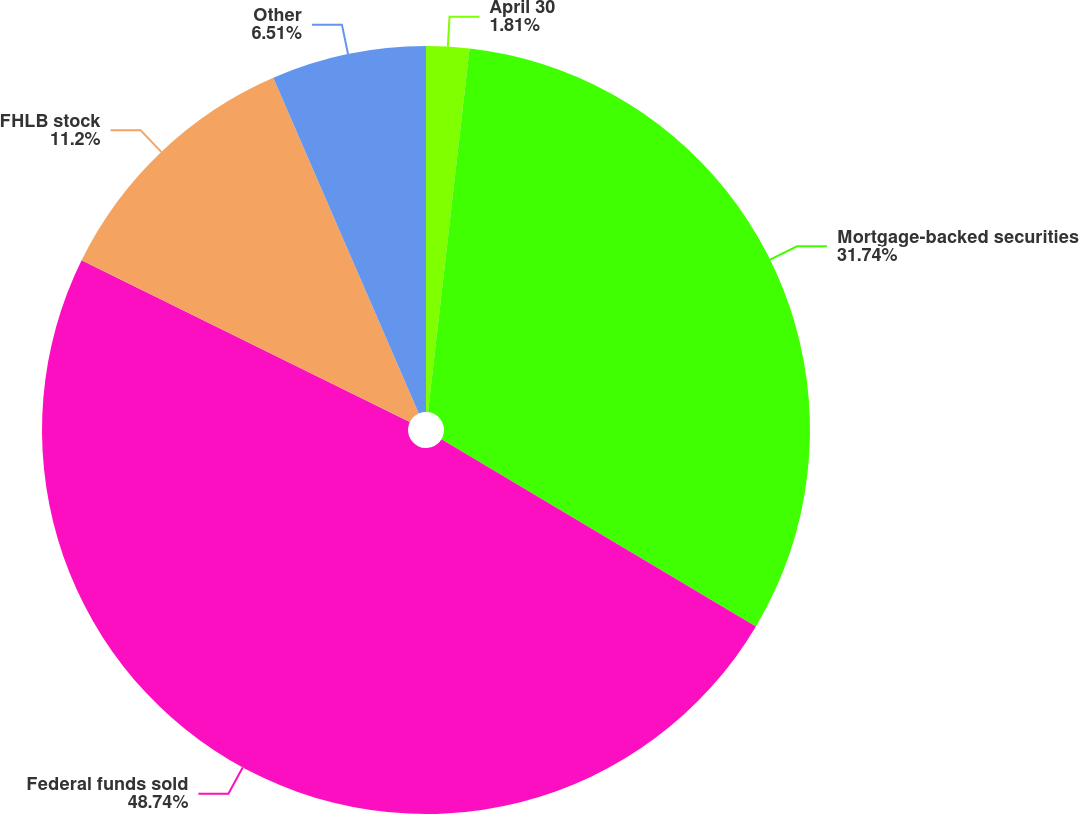<chart> <loc_0><loc_0><loc_500><loc_500><pie_chart><fcel>April 30<fcel>Mortgage-backed securities<fcel>Federal funds sold<fcel>FHLB stock<fcel>Other<nl><fcel>1.81%<fcel>31.74%<fcel>48.74%<fcel>11.2%<fcel>6.51%<nl></chart> 